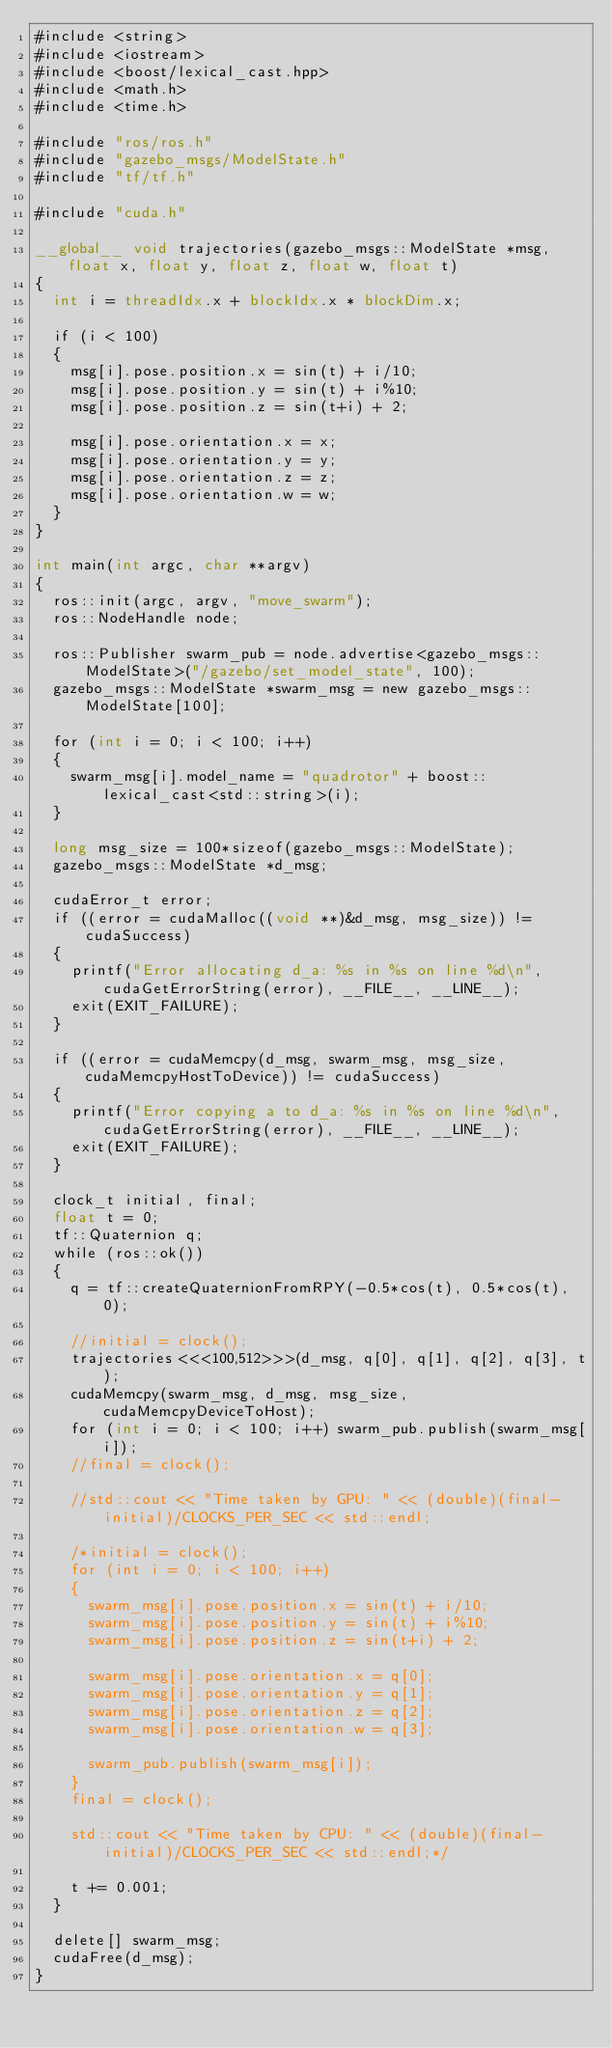Convert code to text. <code><loc_0><loc_0><loc_500><loc_500><_Cuda_>#include <string>
#include <iostream>
#include <boost/lexical_cast.hpp>
#include <math.h>
#include <time.h>

#include "ros/ros.h"
#include "gazebo_msgs/ModelState.h"
#include "tf/tf.h"

#include "cuda.h"

__global__ void trajectories(gazebo_msgs::ModelState *msg, float x, float y, float z, float w, float t)
{
	int i = threadIdx.x + blockIdx.x * blockDim.x;

	if (i < 100)
	{
		msg[i].pose.position.x = sin(t) + i/10;
		msg[i].pose.position.y = sin(t) + i%10;
		msg[i].pose.position.z = sin(t+i) + 2;

		msg[i].pose.orientation.x = x;
		msg[i].pose.orientation.y = y;
		msg[i].pose.orientation.z = z;
		msg[i].pose.orientation.w = w;
	}
}

int main(int argc, char **argv)
{
	ros::init(argc, argv, "move_swarm");
	ros::NodeHandle node;

	ros::Publisher swarm_pub = node.advertise<gazebo_msgs::ModelState>("/gazebo/set_model_state", 100);
	gazebo_msgs::ModelState *swarm_msg = new gazebo_msgs::ModelState[100];

	for (int i = 0; i < 100; i++)
	{
		swarm_msg[i].model_name = "quadrotor" + boost::lexical_cast<std::string>(i);
	}

	long msg_size = 100*sizeof(gazebo_msgs::ModelState);
	gazebo_msgs::ModelState *d_msg;

	cudaError_t error;
	if ((error = cudaMalloc((void **)&d_msg, msg_size)) != cudaSuccess)
	{
		printf("Error allocating d_a: %s in %s on line %d\n", cudaGetErrorString(error), __FILE__, __LINE__);
		exit(EXIT_FAILURE);
	}

	if ((error = cudaMemcpy(d_msg, swarm_msg, msg_size, cudaMemcpyHostToDevice)) != cudaSuccess)
	{
		printf("Error copying a to d_a: %s in %s on line %d\n", cudaGetErrorString(error), __FILE__, __LINE__);
		exit(EXIT_FAILURE);
	}

	clock_t initial, final;
	float t = 0;
	tf::Quaternion q;
	while (ros::ok())
	{
		q = tf::createQuaternionFromRPY(-0.5*cos(t), 0.5*cos(t), 0);

		//initial = clock();
		trajectories<<<100,512>>>(d_msg, q[0], q[1], q[2], q[3], t);
		cudaMemcpy(swarm_msg, d_msg, msg_size, cudaMemcpyDeviceToHost);
		for (int i = 0; i < 100; i++) swarm_pub.publish(swarm_msg[i]);
		//final = clock();

		//std::cout << "Time taken by GPU: " << (double)(final-initial)/CLOCKS_PER_SEC << std::endl;

		/*initial = clock();
		for (int i = 0; i < 100; i++)
		{
			swarm_msg[i].pose.position.x = sin(t) + i/10;
			swarm_msg[i].pose.position.y = sin(t) + i%10;
			swarm_msg[i].pose.position.z = sin(t+i) + 2;

			swarm_msg[i].pose.orientation.x = q[0];
			swarm_msg[i].pose.orientation.y = q[1];
			swarm_msg[i].pose.orientation.z = q[2];
			swarm_msg[i].pose.orientation.w = q[3];

			swarm_pub.publish(swarm_msg[i]);
		}
		final = clock();

		std::cout << "Time taken by CPU: " << (double)(final-initial)/CLOCKS_PER_SEC << std::endl;*/
		
		t += 0.001;
	}

	delete[] swarm_msg;
	cudaFree(d_msg);
}
</code> 